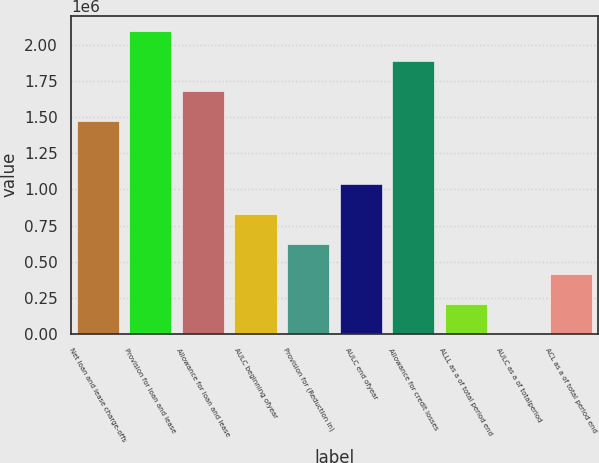Convert chart to OTSL. <chart><loc_0><loc_0><loc_500><loc_500><bar_chart><fcel>Net loan and lease charge-offs<fcel>Provision for loan and lease<fcel>Allowance for loan and lease<fcel>AULC beginning ofyear<fcel>Provision for (Reduction in)<fcel>AULC end ofyear<fcel>Allowance for credit losses<fcel>ALLL as a of total period end<fcel>AULC as a of totalperiod<fcel>ACL as a of total period end<nl><fcel>1.47659e+06<fcel>2.09757e+06<fcel>1.68358e+06<fcel>827972<fcel>620979<fcel>1.03497e+06<fcel>1.89057e+06<fcel>206993<fcel>0.13<fcel>413986<nl></chart> 